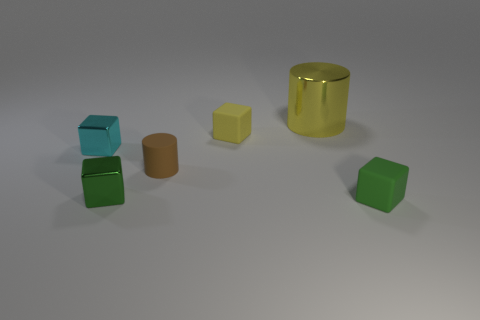Subtract all yellow cubes. How many cubes are left? 3 Subtract all yellow blocks. How many blocks are left? 3 Subtract all cylinders. How many objects are left? 4 Add 4 gray metallic balls. How many objects exist? 10 Subtract 2 cubes. How many cubes are left? 2 Subtract all brown blocks. Subtract all red cylinders. How many blocks are left? 4 Subtract all yellow spheres. How many red cylinders are left? 0 Subtract all small green rubber things. Subtract all big metallic cylinders. How many objects are left? 4 Add 4 large metal objects. How many large metal objects are left? 5 Add 2 gray metal cylinders. How many gray metal cylinders exist? 2 